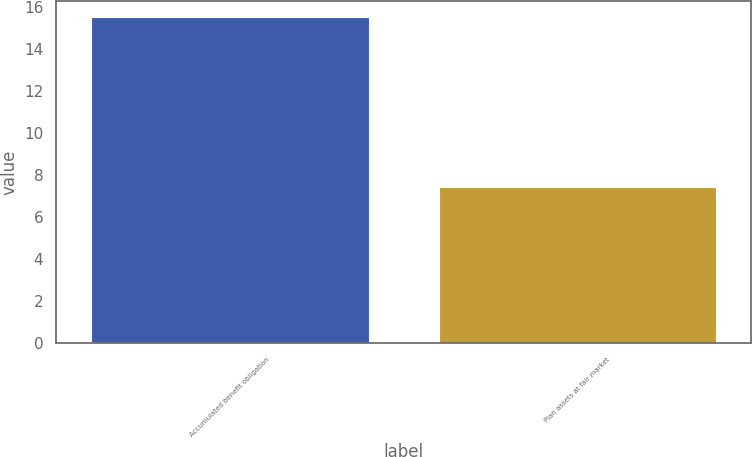Convert chart. <chart><loc_0><loc_0><loc_500><loc_500><bar_chart><fcel>Accumulated benefit obligation<fcel>Plan assets at fair market<nl><fcel>15.5<fcel>7.4<nl></chart> 